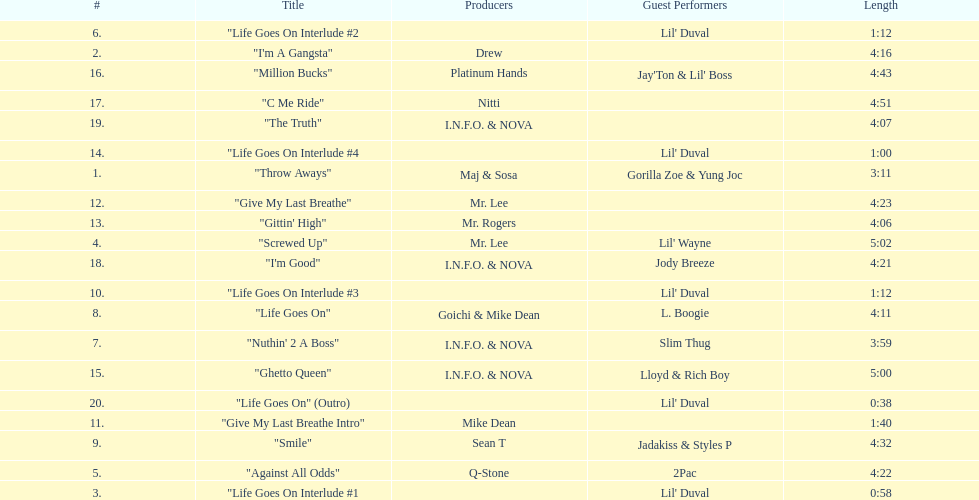Could you parse the entire table as a dict? {'header': ['#', 'Title', 'Producers', 'Guest Performers', 'Length'], 'rows': [['6.', '"Life Goes On Interlude #2', '', "Lil' Duval", '1:12'], ['2.', '"I\'m A Gangsta"', 'Drew', '', '4:16'], ['16.', '"Million Bucks"', 'Platinum Hands', "Jay'Ton & Lil' Boss", '4:43'], ['17.', '"C Me Ride"', 'Nitti', '', '4:51'], ['19.', '"The Truth"', 'I.N.F.O. & NOVA', '', '4:07'], ['14.', '"Life Goes On Interlude #4', '', "Lil' Duval", '1:00'], ['1.', '"Throw Aways"', 'Maj & Sosa', 'Gorilla Zoe & Yung Joc', '3:11'], ['12.', '"Give My Last Breathe"', 'Mr. Lee', '', '4:23'], ['13.', '"Gittin\' High"', 'Mr. Rogers', '', '4:06'], ['4.', '"Screwed Up"', 'Mr. Lee', "Lil' Wayne", '5:02'], ['18.', '"I\'m Good"', 'I.N.F.O. & NOVA', 'Jody Breeze', '4:21'], ['10.', '"Life Goes On Interlude #3', '', "Lil' Duval", '1:12'], ['8.', '"Life Goes On"', 'Goichi & Mike Dean', 'L. Boogie', '4:11'], ['7.', '"Nuthin\' 2 A Boss"', 'I.N.F.O. & NOVA', 'Slim Thug', '3:59'], ['15.', '"Ghetto Queen"', 'I.N.F.O. & NOVA', 'Lloyd & Rich Boy', '5:00'], ['20.', '"Life Goes On" (Outro)', '', "Lil' Duval", '0:38'], ['11.', '"Give My Last Breathe Intro"', 'Mike Dean', '', '1:40'], ['9.', '"Smile"', 'Sean T', 'Jadakiss & Styles P', '4:32'], ['5.', '"Against All Odds"', 'Q-Stone', '2Pac', '4:22'], ['3.', '"Life Goes On Interlude #1', '', "Lil' Duval", '0:58']]} What's the overall count of tracks present on the album? 20. 